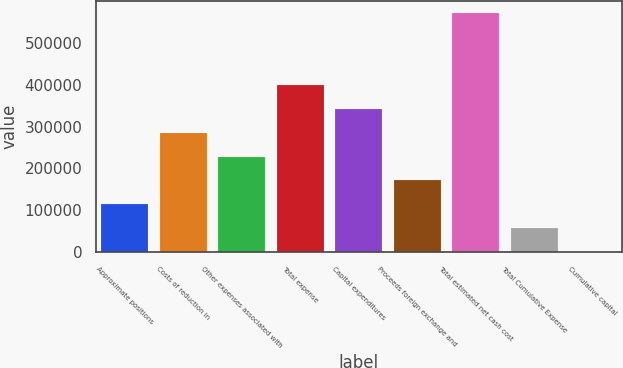Convert chart to OTSL. <chart><loc_0><loc_0><loc_500><loc_500><bar_chart><fcel>Approximate positions<fcel>Costs of reduction in<fcel>Other expenses associated with<fcel>Total expense<fcel>Capital expenditures<fcel>Proceeds foreign exchange and<fcel>Total estimated net cash cost<fcel>Total Cumulative Expense<fcel>Cumulative capital<nl><fcel>114288<fcel>285400<fcel>228362<fcel>399474<fcel>342437<fcel>171325<fcel>570585<fcel>57251.1<fcel>214<nl></chart> 